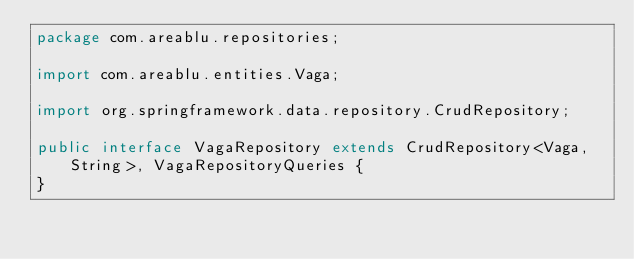Convert code to text. <code><loc_0><loc_0><loc_500><loc_500><_Java_>package com.areablu.repositories;

import com.areablu.entities.Vaga;

import org.springframework.data.repository.CrudRepository;

public interface VagaRepository extends CrudRepository<Vaga, String>, VagaRepositoryQueries {
}
</code> 